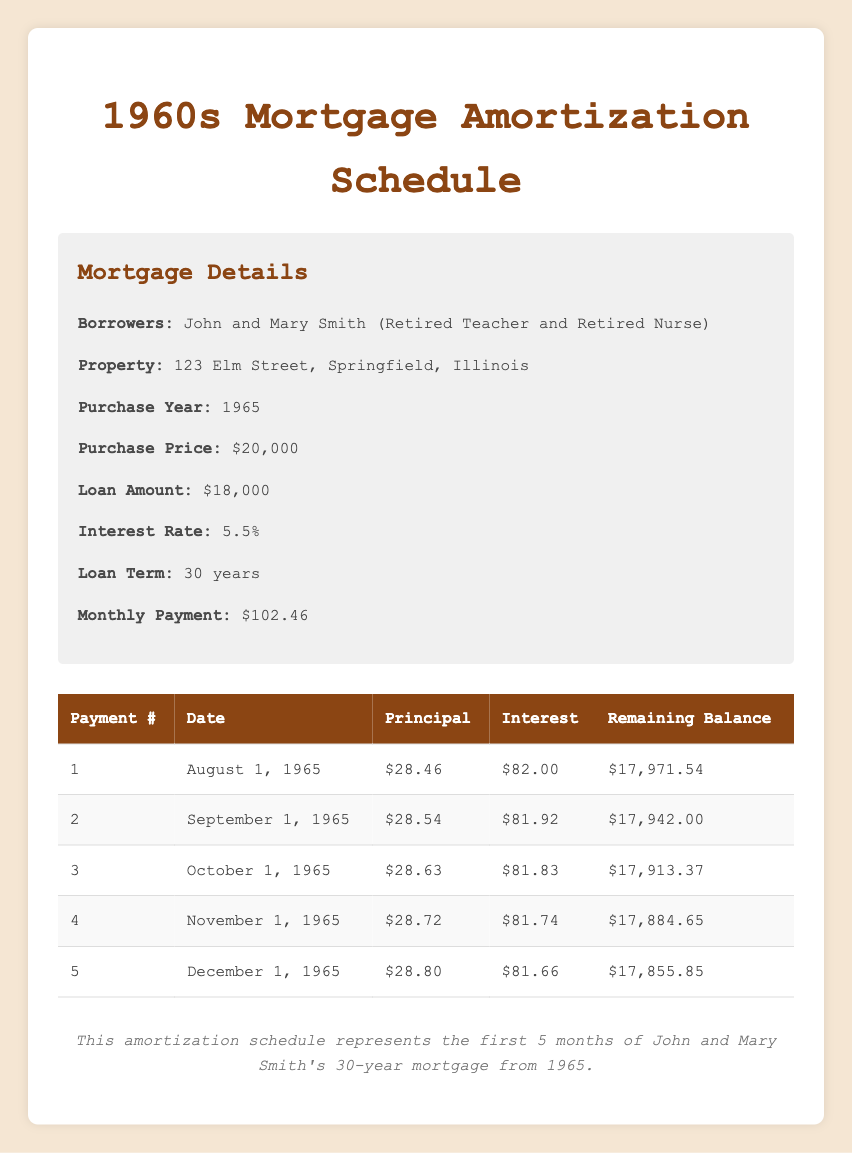What is the purchase price of the house? The purchase price of the house is listed in the mortgage details section. It states that the purchase price is $20,000.
Answer: $20,000 What is the monthly payment amount for this mortgage? The monthly payment amount is also found in the mortgage details. It specifically shows that the monthly payment is $102.46.
Answer: $102.46 How much of the first payment went toward interest? The first payment details indicate that the interest payment for the first month was $82.00.
Answer: $82.00 What is the remaining balance after the second payment? The remaining balance after the second payment is stated in the amortization schedule. According to the table, the remaining balance after payment number 2 is $17,942.00.
Answer: $17,942.00 What is the total principal payment made in the first five months? To find the total principal payment for the first five months, we sum the principal payments for each month: 28.46 + 28.54 + 28.63 + 28.72 + 28.80 = 143.15.
Answer: $143.15 Does the principal payment increase each month? Yes, by observing the principal payment values in each row of the table, we see that each subsequent principal payment is higher than the previous one (28.46, 28.54, 28.63, 28.72, 28.80).
Answer: Yes What was the interest payment for the fourth month? The fourth month's interest payment is found in the table, where it lists the interest payment for payment number 4 as $81.74.
Answer: $81.74 What is the average remaining balance after the first five payments? To calculate the average remaining balance, we take the sum of the remaining balances after each payment: (17971.54 + 17942.00 + 17913.37 + 17884.65 + 17855.85) / 5 = 17913.82.
Answer: $17,913.82 How much more was paid in interest compared to principal in the first payment? From the first payment, the interest paid was $82.00, and the principal paid was $28.46. The difference is $82.00 - $28.46 = $53.54.
Answer: $53.54 